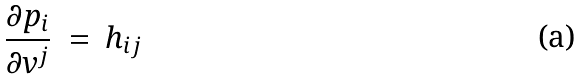Convert formula to latex. <formula><loc_0><loc_0><loc_500><loc_500>\frac { \partial p _ { i } } { \partial v ^ { j } } \ = \ h _ { i j }</formula> 